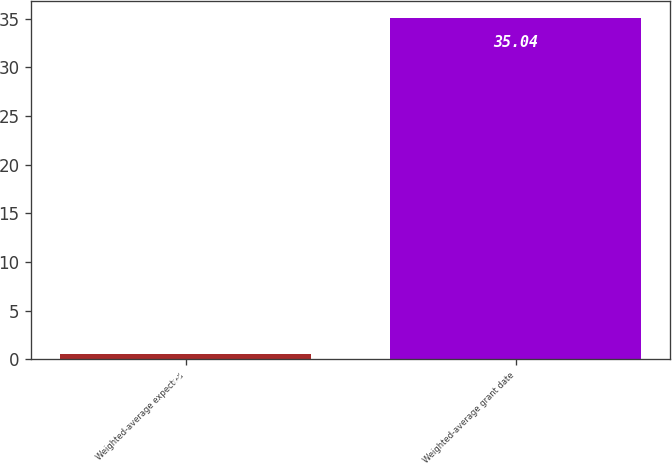Convert chart. <chart><loc_0><loc_0><loc_500><loc_500><bar_chart><fcel>Weighted-average expected<fcel>Weighted-average grant date<nl><fcel>0.5<fcel>35.04<nl></chart> 